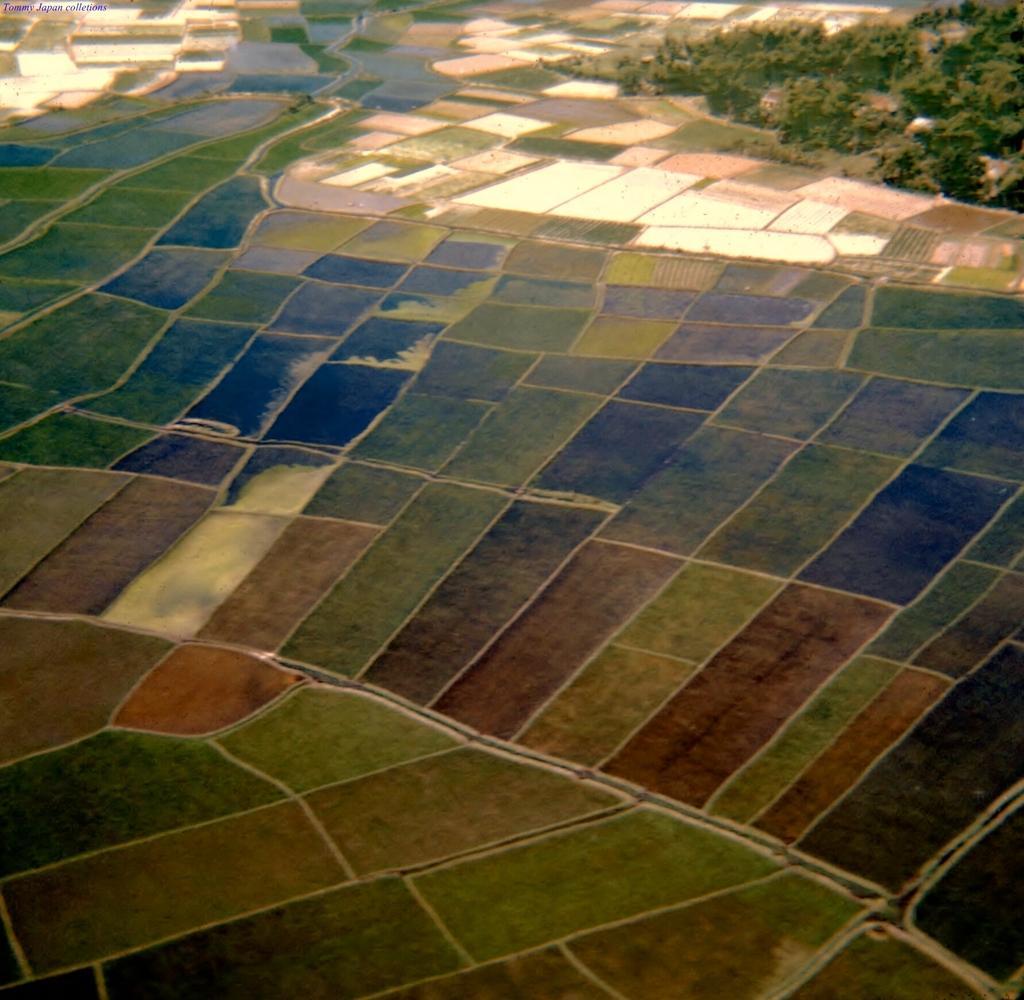Please provide a concise description of this image. As we can see in the image there are different colors of tiles and on the right side background there are plants. 